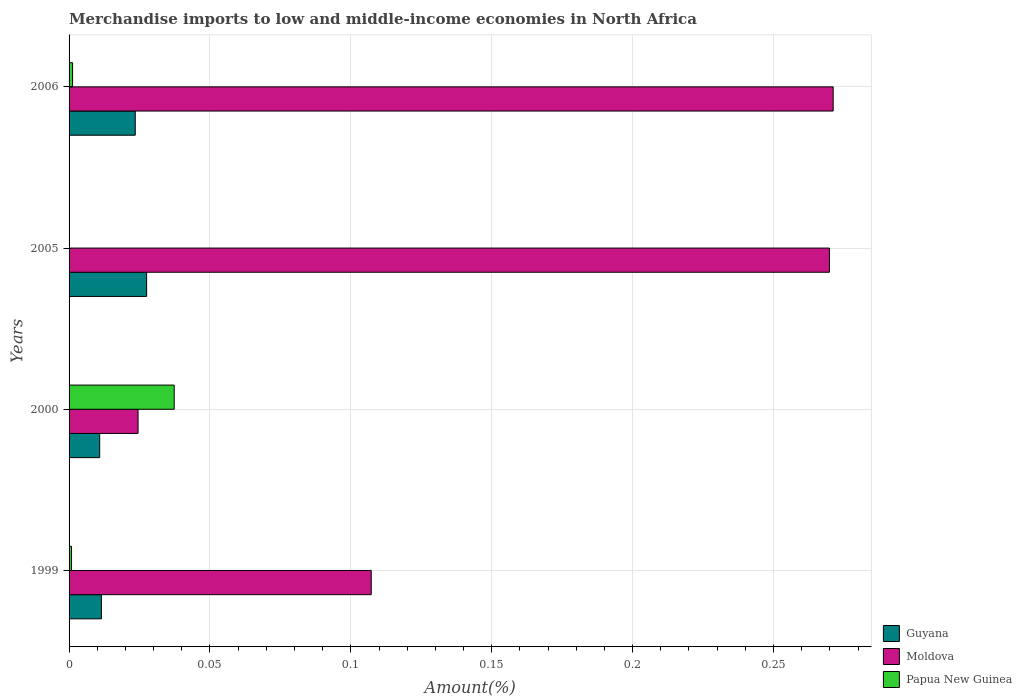Are the number of bars on each tick of the Y-axis equal?
Offer a very short reply. Yes. How many bars are there on the 3rd tick from the top?
Your answer should be very brief. 3. What is the label of the 2nd group of bars from the top?
Give a very brief answer. 2005. In how many cases, is the number of bars for a given year not equal to the number of legend labels?
Ensure brevity in your answer.  0. What is the percentage of amount earned from merchandise imports in Guyana in 2005?
Offer a terse response. 0.03. Across all years, what is the maximum percentage of amount earned from merchandise imports in Guyana?
Give a very brief answer. 0.03. Across all years, what is the minimum percentage of amount earned from merchandise imports in Papua New Guinea?
Keep it short and to the point. 7.19681476465821e-5. In which year was the percentage of amount earned from merchandise imports in Guyana maximum?
Make the answer very short. 2005. In which year was the percentage of amount earned from merchandise imports in Guyana minimum?
Ensure brevity in your answer.  2000. What is the total percentage of amount earned from merchandise imports in Guyana in the graph?
Keep it short and to the point. 0.07. What is the difference between the percentage of amount earned from merchandise imports in Moldova in 2000 and that in 2005?
Offer a terse response. -0.25. What is the difference between the percentage of amount earned from merchandise imports in Moldova in 2006 and the percentage of amount earned from merchandise imports in Guyana in 2005?
Your answer should be very brief. 0.24. What is the average percentage of amount earned from merchandise imports in Guyana per year?
Provide a short and direct response. 0.02. In the year 1999, what is the difference between the percentage of amount earned from merchandise imports in Guyana and percentage of amount earned from merchandise imports in Moldova?
Provide a succinct answer. -0.1. In how many years, is the percentage of amount earned from merchandise imports in Moldova greater than 0.23 %?
Your answer should be very brief. 2. What is the ratio of the percentage of amount earned from merchandise imports in Moldova in 2005 to that in 2006?
Your answer should be compact. 1. What is the difference between the highest and the second highest percentage of amount earned from merchandise imports in Moldova?
Offer a very short reply. 0. What is the difference between the highest and the lowest percentage of amount earned from merchandise imports in Guyana?
Your answer should be very brief. 0.02. In how many years, is the percentage of amount earned from merchandise imports in Guyana greater than the average percentage of amount earned from merchandise imports in Guyana taken over all years?
Your response must be concise. 2. What does the 1st bar from the top in 2005 represents?
Give a very brief answer. Papua New Guinea. What does the 3rd bar from the bottom in 1999 represents?
Offer a terse response. Papua New Guinea. How many bars are there?
Your answer should be very brief. 12. Are all the bars in the graph horizontal?
Offer a very short reply. Yes. What is the difference between two consecutive major ticks on the X-axis?
Offer a very short reply. 0.05. Are the values on the major ticks of X-axis written in scientific E-notation?
Offer a terse response. No. Does the graph contain grids?
Provide a succinct answer. Yes. What is the title of the graph?
Keep it short and to the point. Merchandise imports to low and middle-income economies in North Africa. Does "Marshall Islands" appear as one of the legend labels in the graph?
Ensure brevity in your answer.  No. What is the label or title of the X-axis?
Provide a short and direct response. Amount(%). What is the label or title of the Y-axis?
Provide a short and direct response. Years. What is the Amount(%) of Guyana in 1999?
Provide a short and direct response. 0.01. What is the Amount(%) of Moldova in 1999?
Your answer should be very brief. 0.11. What is the Amount(%) in Papua New Guinea in 1999?
Offer a very short reply. 0. What is the Amount(%) of Guyana in 2000?
Offer a terse response. 0.01. What is the Amount(%) of Moldova in 2000?
Provide a succinct answer. 0.02. What is the Amount(%) in Papua New Guinea in 2000?
Give a very brief answer. 0.04. What is the Amount(%) in Guyana in 2005?
Offer a very short reply. 0.03. What is the Amount(%) in Moldova in 2005?
Offer a terse response. 0.27. What is the Amount(%) in Papua New Guinea in 2005?
Keep it short and to the point. 7.19681476465821e-5. What is the Amount(%) of Guyana in 2006?
Your response must be concise. 0.02. What is the Amount(%) of Moldova in 2006?
Ensure brevity in your answer.  0.27. What is the Amount(%) of Papua New Guinea in 2006?
Your response must be concise. 0. Across all years, what is the maximum Amount(%) in Guyana?
Offer a terse response. 0.03. Across all years, what is the maximum Amount(%) of Moldova?
Ensure brevity in your answer.  0.27. Across all years, what is the maximum Amount(%) of Papua New Guinea?
Ensure brevity in your answer.  0.04. Across all years, what is the minimum Amount(%) of Guyana?
Make the answer very short. 0.01. Across all years, what is the minimum Amount(%) in Moldova?
Ensure brevity in your answer.  0.02. Across all years, what is the minimum Amount(%) of Papua New Guinea?
Keep it short and to the point. 7.19681476465821e-5. What is the total Amount(%) in Guyana in the graph?
Offer a very short reply. 0.07. What is the total Amount(%) in Moldova in the graph?
Offer a terse response. 0.67. What is the total Amount(%) of Papua New Guinea in the graph?
Your response must be concise. 0.04. What is the difference between the Amount(%) of Guyana in 1999 and that in 2000?
Provide a succinct answer. 0. What is the difference between the Amount(%) in Moldova in 1999 and that in 2000?
Make the answer very short. 0.08. What is the difference between the Amount(%) of Papua New Guinea in 1999 and that in 2000?
Your answer should be compact. -0.04. What is the difference between the Amount(%) of Guyana in 1999 and that in 2005?
Keep it short and to the point. -0.02. What is the difference between the Amount(%) in Moldova in 1999 and that in 2005?
Keep it short and to the point. -0.16. What is the difference between the Amount(%) in Papua New Guinea in 1999 and that in 2005?
Ensure brevity in your answer.  0. What is the difference between the Amount(%) in Guyana in 1999 and that in 2006?
Provide a short and direct response. -0.01. What is the difference between the Amount(%) of Moldova in 1999 and that in 2006?
Provide a succinct answer. -0.16. What is the difference between the Amount(%) in Papua New Guinea in 1999 and that in 2006?
Give a very brief answer. -0. What is the difference between the Amount(%) in Guyana in 2000 and that in 2005?
Ensure brevity in your answer.  -0.02. What is the difference between the Amount(%) of Moldova in 2000 and that in 2005?
Your response must be concise. -0.25. What is the difference between the Amount(%) in Papua New Guinea in 2000 and that in 2005?
Your answer should be compact. 0.04. What is the difference between the Amount(%) in Guyana in 2000 and that in 2006?
Your response must be concise. -0.01. What is the difference between the Amount(%) of Moldova in 2000 and that in 2006?
Provide a short and direct response. -0.25. What is the difference between the Amount(%) in Papua New Guinea in 2000 and that in 2006?
Provide a succinct answer. 0.04. What is the difference between the Amount(%) in Guyana in 2005 and that in 2006?
Provide a short and direct response. 0. What is the difference between the Amount(%) of Moldova in 2005 and that in 2006?
Your response must be concise. -0. What is the difference between the Amount(%) of Papua New Guinea in 2005 and that in 2006?
Provide a short and direct response. -0. What is the difference between the Amount(%) of Guyana in 1999 and the Amount(%) of Moldova in 2000?
Ensure brevity in your answer.  -0.01. What is the difference between the Amount(%) of Guyana in 1999 and the Amount(%) of Papua New Guinea in 2000?
Your answer should be compact. -0.03. What is the difference between the Amount(%) in Moldova in 1999 and the Amount(%) in Papua New Guinea in 2000?
Ensure brevity in your answer.  0.07. What is the difference between the Amount(%) of Guyana in 1999 and the Amount(%) of Moldova in 2005?
Provide a short and direct response. -0.26. What is the difference between the Amount(%) in Guyana in 1999 and the Amount(%) in Papua New Guinea in 2005?
Keep it short and to the point. 0.01. What is the difference between the Amount(%) of Moldova in 1999 and the Amount(%) of Papua New Guinea in 2005?
Offer a terse response. 0.11. What is the difference between the Amount(%) in Guyana in 1999 and the Amount(%) in Moldova in 2006?
Keep it short and to the point. -0.26. What is the difference between the Amount(%) in Guyana in 1999 and the Amount(%) in Papua New Guinea in 2006?
Offer a very short reply. 0.01. What is the difference between the Amount(%) of Moldova in 1999 and the Amount(%) of Papua New Guinea in 2006?
Provide a short and direct response. 0.11. What is the difference between the Amount(%) in Guyana in 2000 and the Amount(%) in Moldova in 2005?
Keep it short and to the point. -0.26. What is the difference between the Amount(%) of Guyana in 2000 and the Amount(%) of Papua New Guinea in 2005?
Your answer should be compact. 0.01. What is the difference between the Amount(%) in Moldova in 2000 and the Amount(%) in Papua New Guinea in 2005?
Your answer should be very brief. 0.02. What is the difference between the Amount(%) of Guyana in 2000 and the Amount(%) of Moldova in 2006?
Offer a terse response. -0.26. What is the difference between the Amount(%) of Guyana in 2000 and the Amount(%) of Papua New Guinea in 2006?
Keep it short and to the point. 0.01. What is the difference between the Amount(%) of Moldova in 2000 and the Amount(%) of Papua New Guinea in 2006?
Give a very brief answer. 0.02. What is the difference between the Amount(%) of Guyana in 2005 and the Amount(%) of Moldova in 2006?
Ensure brevity in your answer.  -0.24. What is the difference between the Amount(%) in Guyana in 2005 and the Amount(%) in Papua New Guinea in 2006?
Your answer should be very brief. 0.03. What is the difference between the Amount(%) of Moldova in 2005 and the Amount(%) of Papua New Guinea in 2006?
Offer a terse response. 0.27. What is the average Amount(%) in Guyana per year?
Keep it short and to the point. 0.02. What is the average Amount(%) in Moldova per year?
Your answer should be compact. 0.17. What is the average Amount(%) in Papua New Guinea per year?
Your response must be concise. 0.01. In the year 1999, what is the difference between the Amount(%) in Guyana and Amount(%) in Moldova?
Offer a very short reply. -0.1. In the year 1999, what is the difference between the Amount(%) in Guyana and Amount(%) in Papua New Guinea?
Offer a very short reply. 0.01. In the year 1999, what is the difference between the Amount(%) of Moldova and Amount(%) of Papua New Guinea?
Your response must be concise. 0.11. In the year 2000, what is the difference between the Amount(%) of Guyana and Amount(%) of Moldova?
Provide a short and direct response. -0.01. In the year 2000, what is the difference between the Amount(%) of Guyana and Amount(%) of Papua New Guinea?
Your response must be concise. -0.03. In the year 2000, what is the difference between the Amount(%) in Moldova and Amount(%) in Papua New Guinea?
Provide a short and direct response. -0.01. In the year 2005, what is the difference between the Amount(%) of Guyana and Amount(%) of Moldova?
Ensure brevity in your answer.  -0.24. In the year 2005, what is the difference between the Amount(%) of Guyana and Amount(%) of Papua New Guinea?
Offer a very short reply. 0.03. In the year 2005, what is the difference between the Amount(%) of Moldova and Amount(%) of Papua New Guinea?
Make the answer very short. 0.27. In the year 2006, what is the difference between the Amount(%) of Guyana and Amount(%) of Moldova?
Your response must be concise. -0.25. In the year 2006, what is the difference between the Amount(%) in Guyana and Amount(%) in Papua New Guinea?
Ensure brevity in your answer.  0.02. In the year 2006, what is the difference between the Amount(%) in Moldova and Amount(%) in Papua New Guinea?
Your answer should be compact. 0.27. What is the ratio of the Amount(%) in Guyana in 1999 to that in 2000?
Your answer should be compact. 1.06. What is the ratio of the Amount(%) in Moldova in 1999 to that in 2000?
Keep it short and to the point. 4.38. What is the ratio of the Amount(%) in Papua New Guinea in 1999 to that in 2000?
Offer a terse response. 0.02. What is the ratio of the Amount(%) in Guyana in 1999 to that in 2005?
Provide a succinct answer. 0.42. What is the ratio of the Amount(%) of Moldova in 1999 to that in 2005?
Make the answer very short. 0.4. What is the ratio of the Amount(%) of Papua New Guinea in 1999 to that in 2005?
Provide a short and direct response. 12.12. What is the ratio of the Amount(%) of Guyana in 1999 to that in 2006?
Offer a very short reply. 0.49. What is the ratio of the Amount(%) of Moldova in 1999 to that in 2006?
Keep it short and to the point. 0.4. What is the ratio of the Amount(%) in Papua New Guinea in 1999 to that in 2006?
Keep it short and to the point. 0.7. What is the ratio of the Amount(%) in Guyana in 2000 to that in 2005?
Ensure brevity in your answer.  0.39. What is the ratio of the Amount(%) in Moldova in 2000 to that in 2005?
Ensure brevity in your answer.  0.09. What is the ratio of the Amount(%) of Papua New Guinea in 2000 to that in 2005?
Provide a succinct answer. 518.41. What is the ratio of the Amount(%) in Guyana in 2000 to that in 2006?
Make the answer very short. 0.46. What is the ratio of the Amount(%) of Moldova in 2000 to that in 2006?
Provide a short and direct response. 0.09. What is the ratio of the Amount(%) in Papua New Guinea in 2000 to that in 2006?
Your response must be concise. 29.94. What is the ratio of the Amount(%) in Guyana in 2005 to that in 2006?
Your answer should be very brief. 1.17. What is the ratio of the Amount(%) in Moldova in 2005 to that in 2006?
Your response must be concise. 1. What is the ratio of the Amount(%) of Papua New Guinea in 2005 to that in 2006?
Your answer should be very brief. 0.06. What is the difference between the highest and the second highest Amount(%) of Guyana?
Provide a short and direct response. 0. What is the difference between the highest and the second highest Amount(%) of Moldova?
Make the answer very short. 0. What is the difference between the highest and the second highest Amount(%) of Papua New Guinea?
Your answer should be compact. 0.04. What is the difference between the highest and the lowest Amount(%) of Guyana?
Offer a terse response. 0.02. What is the difference between the highest and the lowest Amount(%) of Moldova?
Provide a short and direct response. 0.25. What is the difference between the highest and the lowest Amount(%) in Papua New Guinea?
Keep it short and to the point. 0.04. 